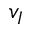Convert formula to latex. <formula><loc_0><loc_0><loc_500><loc_500>v _ { I }</formula> 